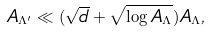<formula> <loc_0><loc_0><loc_500><loc_500>A _ { \Lambda ^ { \prime } } \ll ( \sqrt { d } + \sqrt { \log A _ { \Lambda } } ) A _ { \Lambda } ,</formula> 